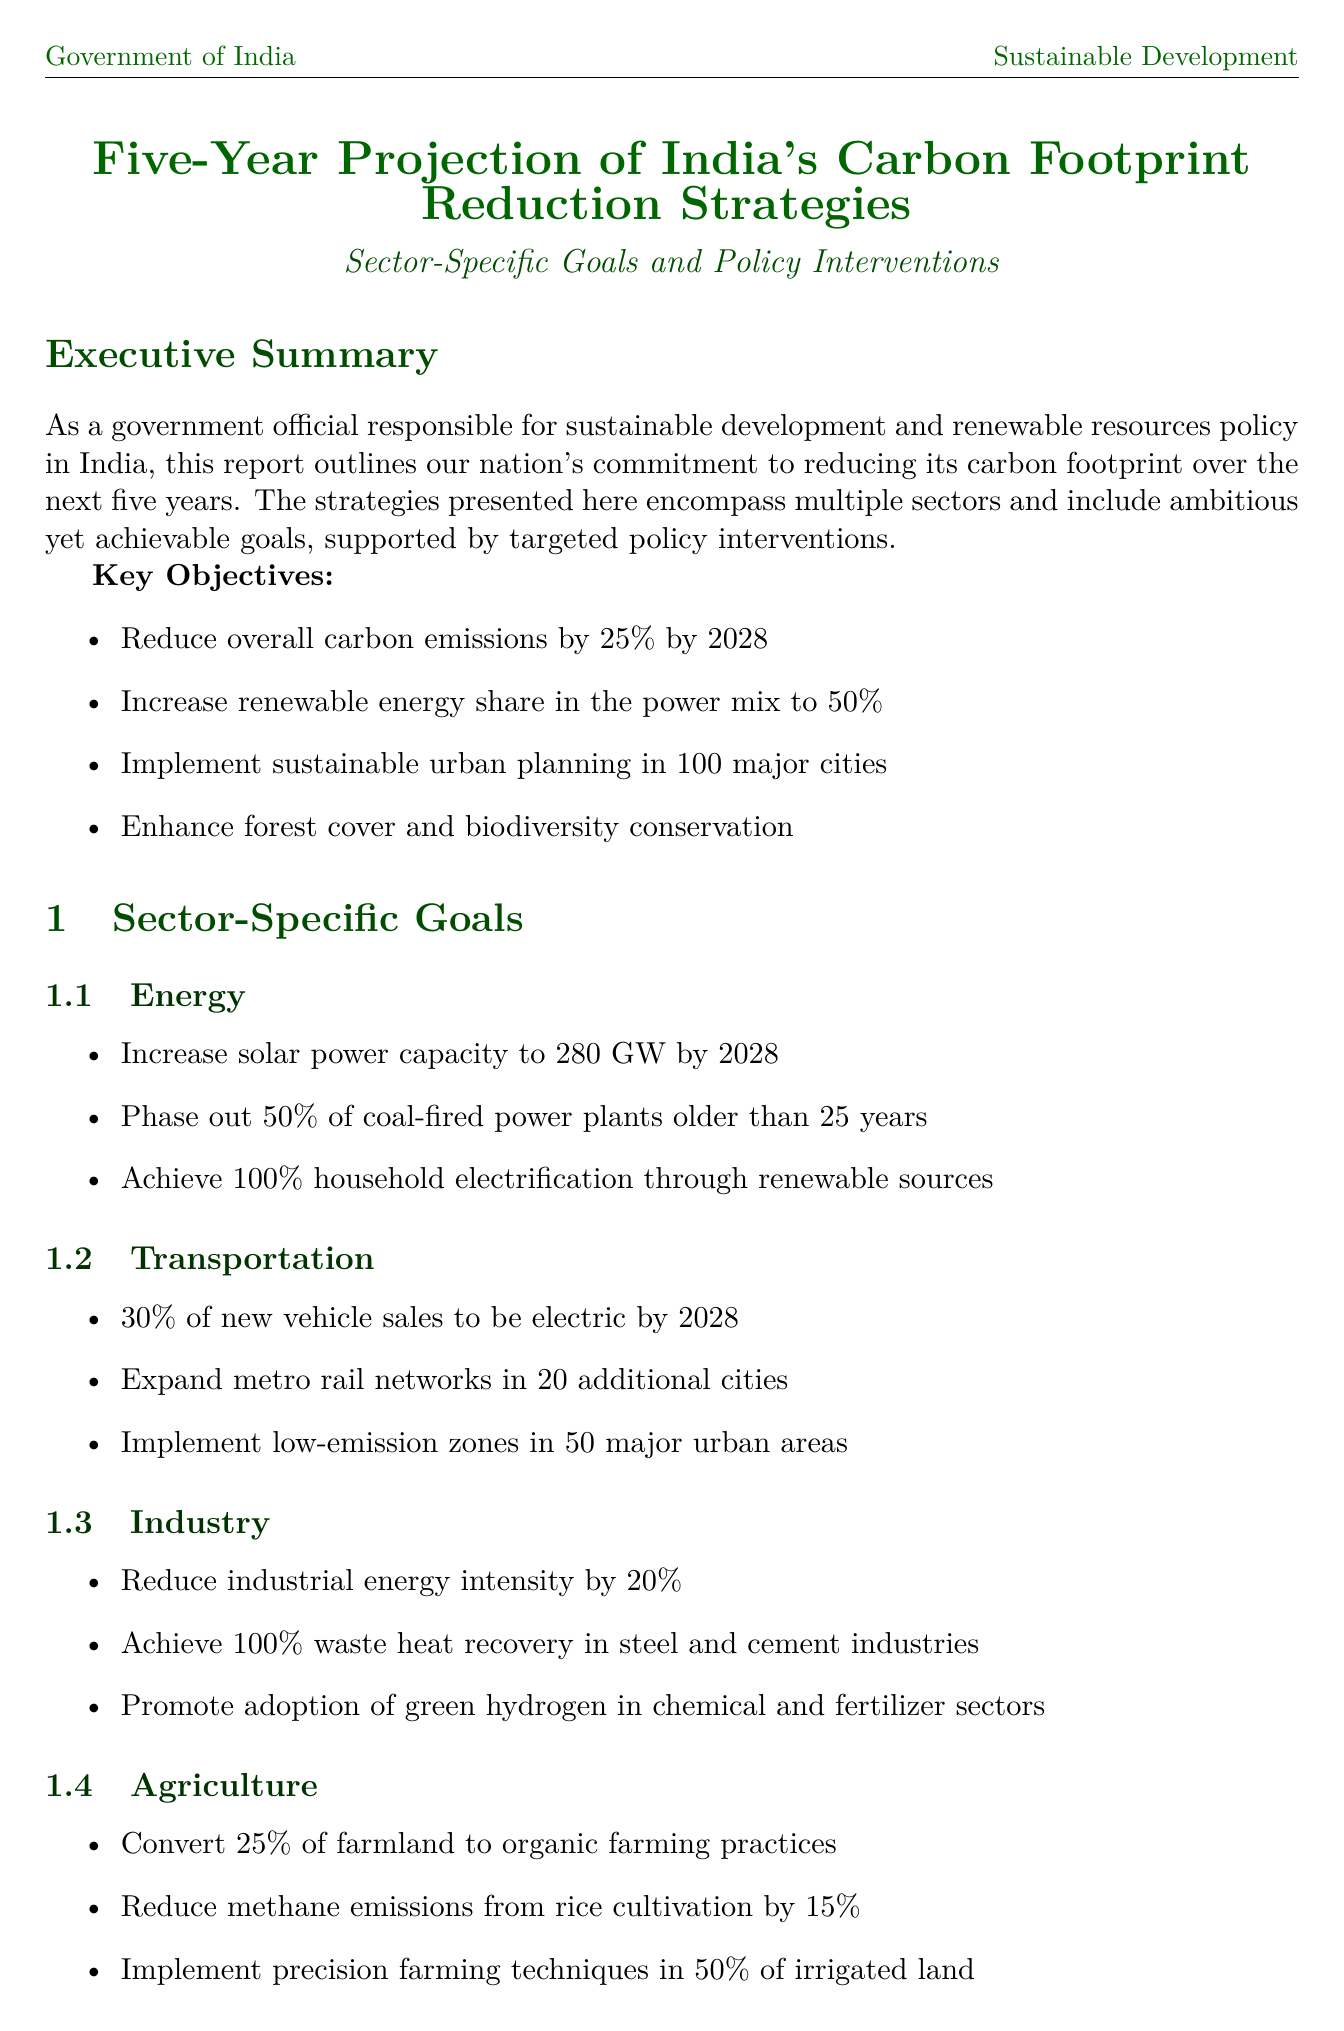What is the carbon emissions reduction target by 2028? The target is specified in the key objectives as a 25% reduction in overall carbon emissions by 2028.
Answer: 25% What is the proposed solar power capacity by 2028? The report details a goal to increase solar power capacity to 280 GW by 2028.
Answer: 280 GW How many cities will have sustainable urban planning implemented? The report states that sustainable urban planning will be implemented in 100 major cities.
Answer: 100 What is the percentage of electric vehicle sales target by 2028? The transport sector goal specifies that 30% of new vehicle sales will be electric by 2028.
Answer: 30% Which ministry is responsible for renewable energy projects? The key stakeholders section identifies the Ministry of New and Renewable Energy as responsible for renewable energy projects and policies.
Answer: Ministry of New and Renewable Energy What year will the Urban Green Transformation Project be launched in 50 cities? The implementation timeline indicates this project is set for launch in the year 2027.
Answer: 2027 How much will the coal cess be increased to under the National Clean Energy Fund Enhancement policy? The document specifies that the coal cess will be increased to ₹800 per tonne.
Answer: ₹800 What is the aimed percentage of renewable energy share in the power mix by 2028? The key objectives indicate that the aim is to reach a 50% share of renewable energy in the power mix by 2028.
Answer: 50% What is the purpose of the Industrial Decarbonization Program? The report describes this program as introducing a cap-and-trade system for energy-intensive industries and providing financial support for upgrades.
Answer: Cap-and-trade system 